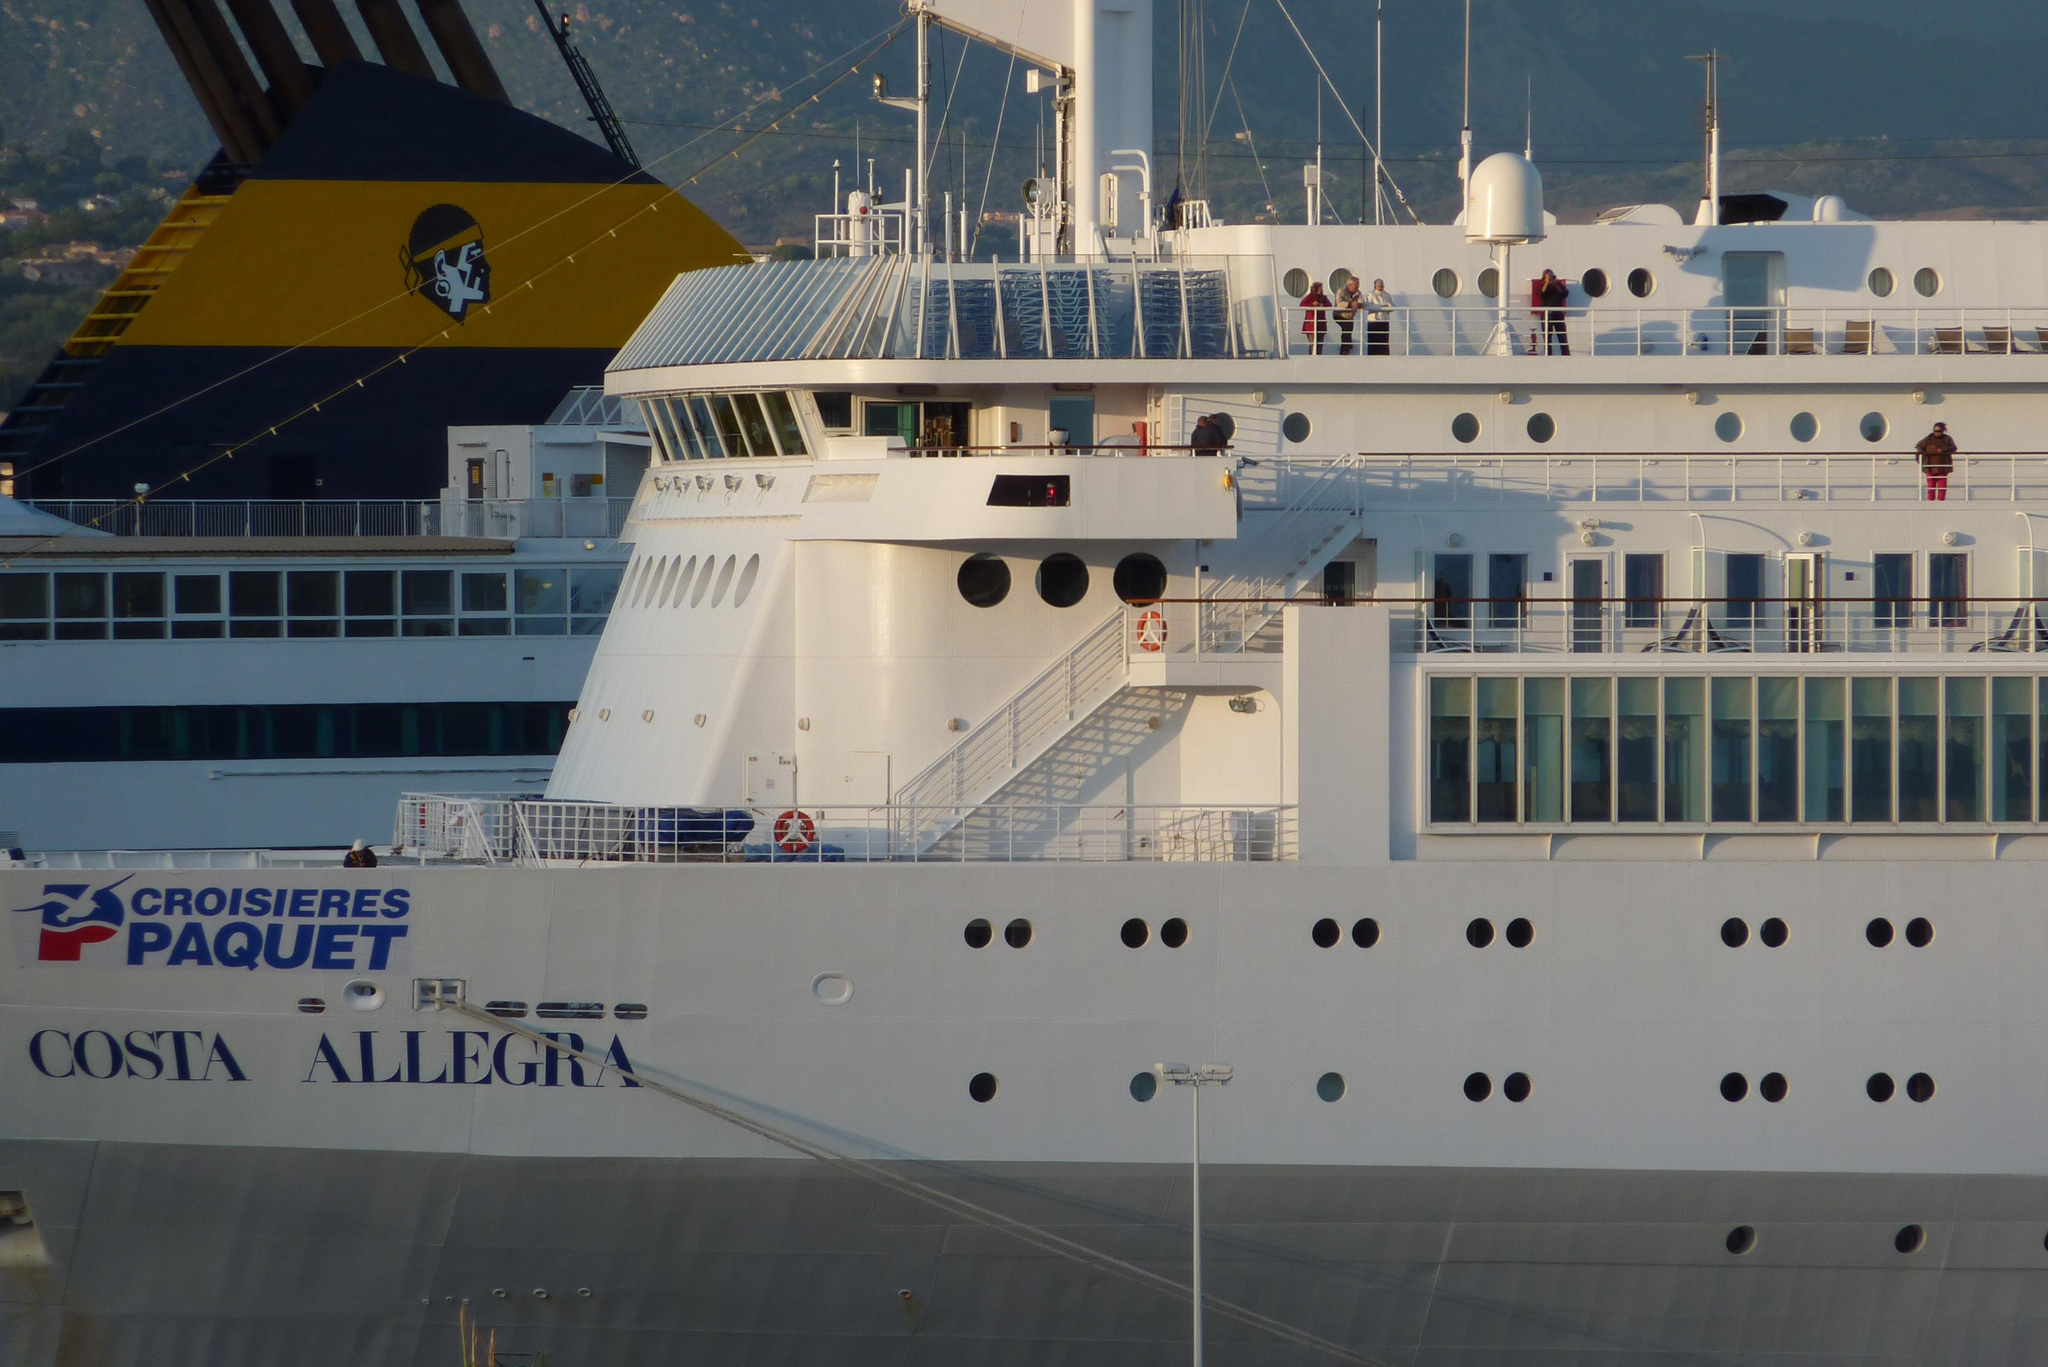What is the main subject of the image? The main subject of the image is a huge boat. Are there any people on the boat? Yes, there are people standing on the boat. Can you describe the surrounding environment in the image? There is another boat behind the first boat, and the sky is visible above the boats. What type of rake is being used to clean the deck of the boat in the image? There is no rake present in the image; it only shows a huge boat with people on it and another boat behind it. 